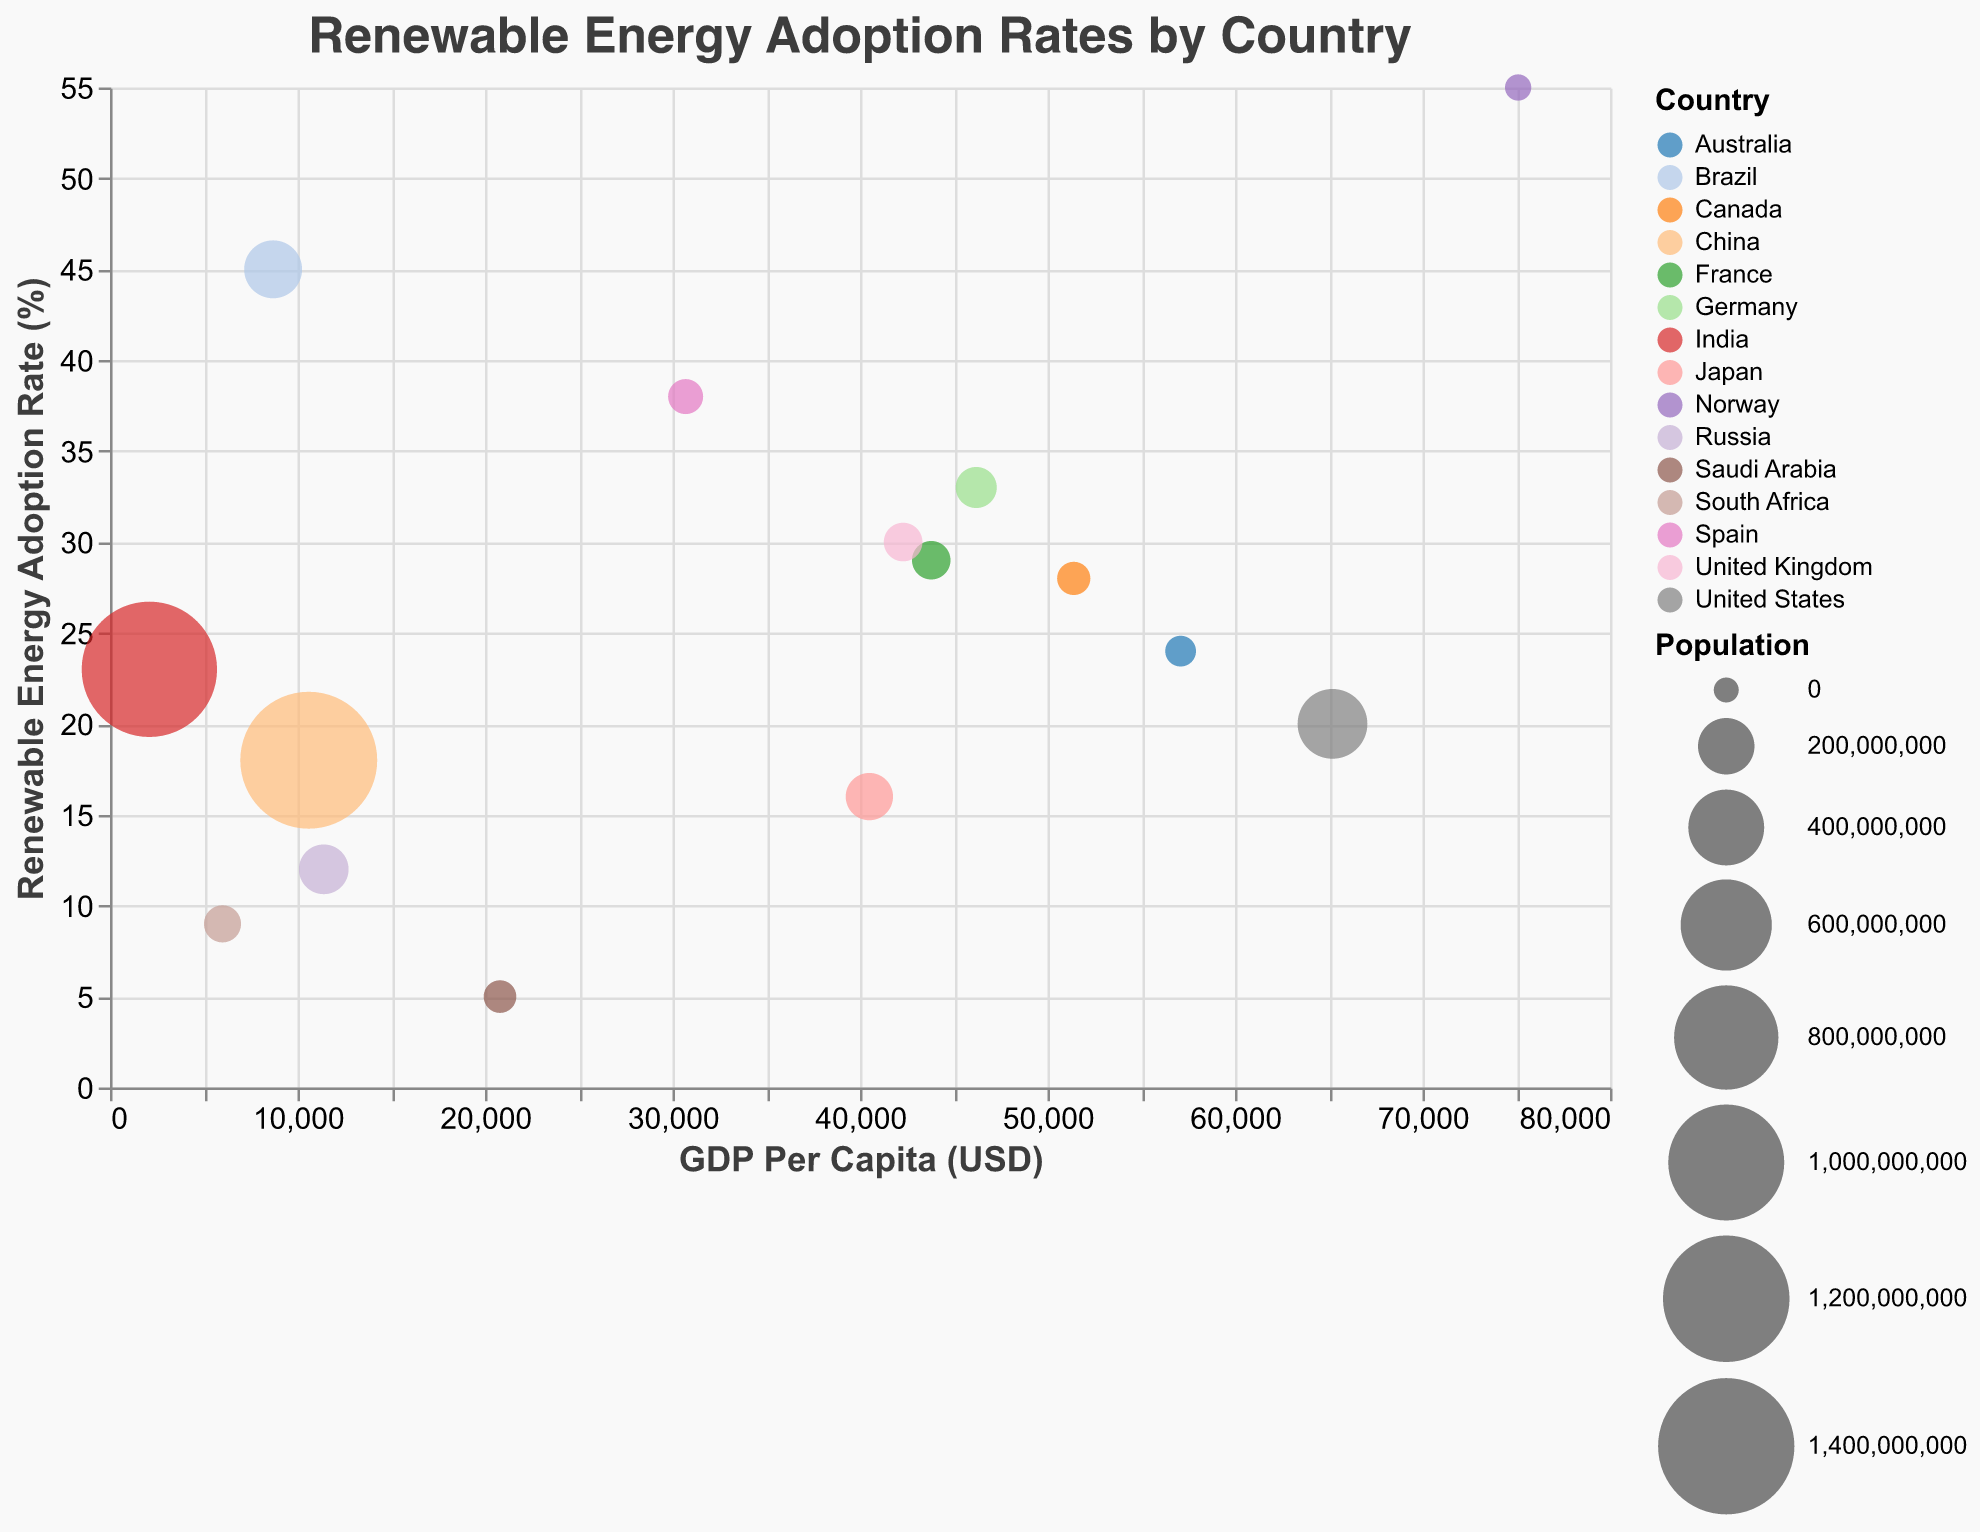What's the title of the chart? The title of the chart is displayed at the top and indicates the topic it presents. The title reads "Renewable Energy Adoption Rates by Country."
Answer: Renewable Energy Adoption Rates by Country Which country has the highest renewable energy adoption rate? By observing the y-axis (Renewable Energy Adoption Rate) and identifying the highest circle, Norway has the highest adoption rate at 55%.
Answer: Norway How is Germany's renewable energy adoption rate compared to that of Japan? Locate the circles representing Germany and Japan on the chart. Germany is at 33% and Japan is at 16%.
Answer: Germany's adoption rate is higher What is the GDP per capita of the United States, and how does it compare to Canada's GDP per capita? Find the circles representing the United States and Canada on the x-axis (GDP Per Capita). The United States is at $65,200, and Canada is at $51,400.
Answer: The United States has a higher GDP per capita Which countries are located closest to each other on the chart in terms of renewable energy adoption rate and GDP per capita? Look for countries with overlapping or adjacent circles. Germany and France are close to each other with adoption rates of 33% and 29%, and GDP per capita of $46,200 and $43,800, respectively.
Answer: Germany and France How does India's renewable energy adoption rate compare to Brazil's adoption rate? Locate India and Brazil on the y-axis. India has an adoption rate of 23%, while Brazil has a higher adoption rate of 45%.
Answer: Brazil's adoption rate is higher Which country has the largest population, and what is its renewable energy adoption rate? Identify the largest circle, which represents China, with the highest population. China's renewable energy adoption rate is 18%.
Answer: China, 18% What is the renewable energy adoption rate for countries with a GDP per capita below $10,000? Look for circles with GDP per capita values below $10,000 on the x-axis: China (18%), India (23%), Brazil (45%), South Africa (9%), and Russia (12%).
Answer: 18%, 23%, 45%, 9%, 12% Which country has a similar renewable energy adoption rate but a higher GDP per capita compared to Spain? Spain has an adoption rate of 38%. The country with a similar rate but higher GDP is Germany with 33% adoption rate but a GDP per capita of $46,200.
Answer: Germany What is France's renewable energy adoption rate and how does it compare to the United Kingdom? France has an adoption rate of 29%, while the United Kingdom has a slightly higher rate of 30%.
Answer: The United Kingdom's rate is slightly higher 